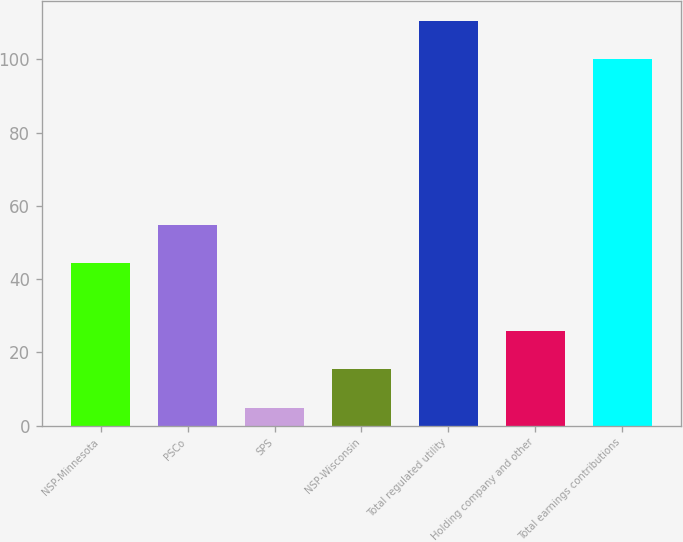Convert chart. <chart><loc_0><loc_0><loc_500><loc_500><bar_chart><fcel>NSP-Minnesota<fcel>PSCo<fcel>SPS<fcel>NSP-Wisconsin<fcel>Total regulated utility<fcel>Holding company and other<fcel>Total earnings contributions<nl><fcel>44.3<fcel>54.71<fcel>4.9<fcel>15.31<fcel>110.41<fcel>25.72<fcel>100<nl></chart> 